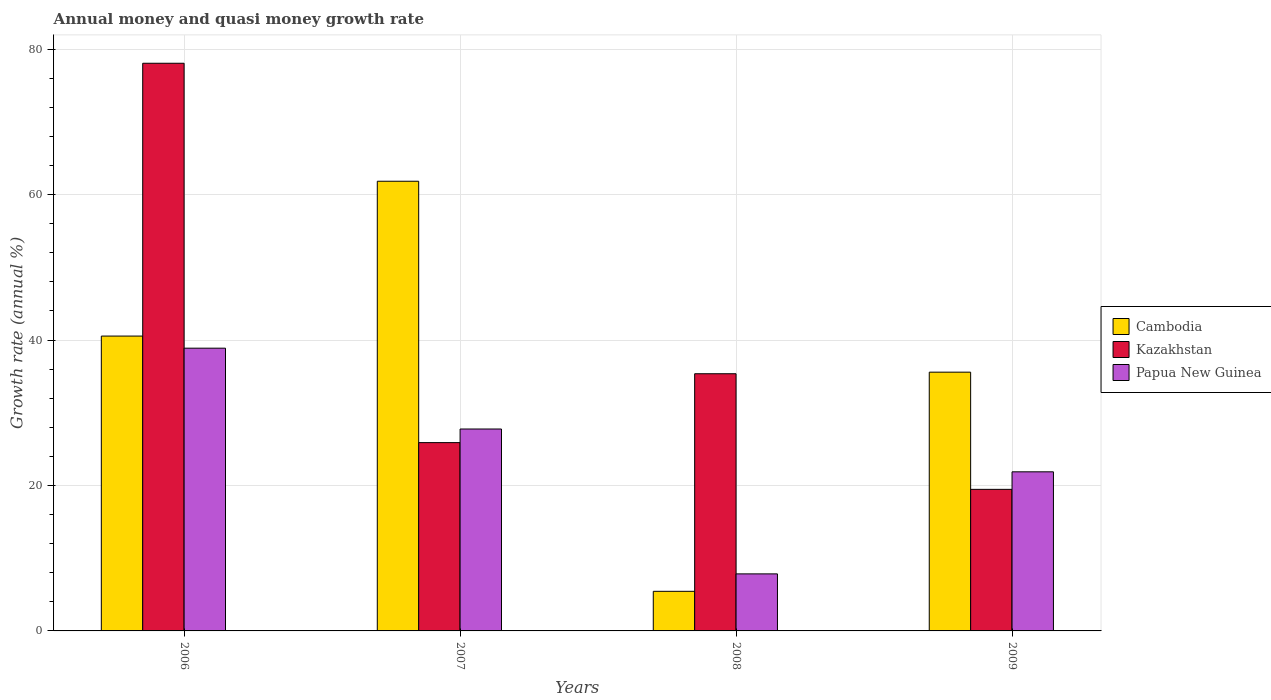How many groups of bars are there?
Make the answer very short. 4. How many bars are there on the 2nd tick from the left?
Provide a short and direct response. 3. How many bars are there on the 4th tick from the right?
Offer a very short reply. 3. What is the label of the 3rd group of bars from the left?
Offer a terse response. 2008. What is the growth rate in Cambodia in 2006?
Offer a very short reply. 40.55. Across all years, what is the maximum growth rate in Cambodia?
Your answer should be very brief. 61.84. Across all years, what is the minimum growth rate in Papua New Guinea?
Your answer should be compact. 7.84. What is the total growth rate in Cambodia in the graph?
Give a very brief answer. 143.41. What is the difference between the growth rate in Kazakhstan in 2007 and that in 2009?
Ensure brevity in your answer.  6.43. What is the difference between the growth rate in Cambodia in 2008 and the growth rate in Kazakhstan in 2009?
Your response must be concise. -14.02. What is the average growth rate in Kazakhstan per year?
Your response must be concise. 39.7. In the year 2006, what is the difference between the growth rate in Papua New Guinea and growth rate in Cambodia?
Your response must be concise. -1.67. What is the ratio of the growth rate in Kazakhstan in 2007 to that in 2008?
Make the answer very short. 0.73. What is the difference between the highest and the second highest growth rate in Papua New Guinea?
Provide a short and direct response. 11.11. What is the difference between the highest and the lowest growth rate in Cambodia?
Offer a very short reply. 56.39. Is the sum of the growth rate in Cambodia in 2006 and 2007 greater than the maximum growth rate in Papua New Guinea across all years?
Your response must be concise. Yes. What does the 2nd bar from the left in 2006 represents?
Offer a very short reply. Kazakhstan. What does the 1st bar from the right in 2009 represents?
Give a very brief answer. Papua New Guinea. Is it the case that in every year, the sum of the growth rate in Kazakhstan and growth rate in Cambodia is greater than the growth rate in Papua New Guinea?
Your response must be concise. Yes. How many bars are there?
Ensure brevity in your answer.  12. How many years are there in the graph?
Make the answer very short. 4. Are the values on the major ticks of Y-axis written in scientific E-notation?
Ensure brevity in your answer.  No. Does the graph contain grids?
Keep it short and to the point. Yes. How are the legend labels stacked?
Offer a terse response. Vertical. What is the title of the graph?
Give a very brief answer. Annual money and quasi money growth rate. What is the label or title of the X-axis?
Make the answer very short. Years. What is the label or title of the Y-axis?
Provide a short and direct response. Growth rate (annual %). What is the Growth rate (annual %) of Cambodia in 2006?
Your answer should be compact. 40.55. What is the Growth rate (annual %) in Kazakhstan in 2006?
Offer a terse response. 78.06. What is the Growth rate (annual %) in Papua New Guinea in 2006?
Provide a succinct answer. 38.88. What is the Growth rate (annual %) in Cambodia in 2007?
Your answer should be very brief. 61.84. What is the Growth rate (annual %) of Kazakhstan in 2007?
Keep it short and to the point. 25.89. What is the Growth rate (annual %) in Papua New Guinea in 2007?
Ensure brevity in your answer.  27.76. What is the Growth rate (annual %) of Cambodia in 2008?
Offer a very short reply. 5.45. What is the Growth rate (annual %) of Kazakhstan in 2008?
Give a very brief answer. 35.37. What is the Growth rate (annual %) of Papua New Guinea in 2008?
Offer a terse response. 7.84. What is the Growth rate (annual %) in Cambodia in 2009?
Your answer should be compact. 35.58. What is the Growth rate (annual %) of Kazakhstan in 2009?
Your answer should be very brief. 19.47. What is the Growth rate (annual %) in Papua New Guinea in 2009?
Your answer should be compact. 21.88. Across all years, what is the maximum Growth rate (annual %) in Cambodia?
Provide a short and direct response. 61.84. Across all years, what is the maximum Growth rate (annual %) in Kazakhstan?
Provide a short and direct response. 78.06. Across all years, what is the maximum Growth rate (annual %) of Papua New Guinea?
Provide a succinct answer. 38.88. Across all years, what is the minimum Growth rate (annual %) in Cambodia?
Your answer should be compact. 5.45. Across all years, what is the minimum Growth rate (annual %) of Kazakhstan?
Offer a very short reply. 19.47. Across all years, what is the minimum Growth rate (annual %) in Papua New Guinea?
Keep it short and to the point. 7.84. What is the total Growth rate (annual %) in Cambodia in the graph?
Ensure brevity in your answer.  143.41. What is the total Growth rate (annual %) in Kazakhstan in the graph?
Give a very brief answer. 158.79. What is the total Growth rate (annual %) in Papua New Guinea in the graph?
Provide a short and direct response. 96.36. What is the difference between the Growth rate (annual %) in Cambodia in 2006 and that in 2007?
Provide a short and direct response. -21.29. What is the difference between the Growth rate (annual %) of Kazakhstan in 2006 and that in 2007?
Offer a terse response. 52.17. What is the difference between the Growth rate (annual %) of Papua New Guinea in 2006 and that in 2007?
Your answer should be very brief. 11.11. What is the difference between the Growth rate (annual %) of Cambodia in 2006 and that in 2008?
Your answer should be compact. 35.1. What is the difference between the Growth rate (annual %) of Kazakhstan in 2006 and that in 2008?
Your answer should be compact. 42.69. What is the difference between the Growth rate (annual %) in Papua New Guinea in 2006 and that in 2008?
Make the answer very short. 31.04. What is the difference between the Growth rate (annual %) of Cambodia in 2006 and that in 2009?
Your answer should be compact. 4.96. What is the difference between the Growth rate (annual %) of Kazakhstan in 2006 and that in 2009?
Your response must be concise. 58.59. What is the difference between the Growth rate (annual %) in Papua New Guinea in 2006 and that in 2009?
Your response must be concise. 17. What is the difference between the Growth rate (annual %) in Cambodia in 2007 and that in 2008?
Your answer should be compact. 56.39. What is the difference between the Growth rate (annual %) of Kazakhstan in 2007 and that in 2008?
Make the answer very short. -9.47. What is the difference between the Growth rate (annual %) of Papua New Guinea in 2007 and that in 2008?
Your answer should be compact. 19.92. What is the difference between the Growth rate (annual %) in Cambodia in 2007 and that in 2009?
Keep it short and to the point. 26.25. What is the difference between the Growth rate (annual %) of Kazakhstan in 2007 and that in 2009?
Your answer should be very brief. 6.43. What is the difference between the Growth rate (annual %) in Papua New Guinea in 2007 and that in 2009?
Provide a short and direct response. 5.89. What is the difference between the Growth rate (annual %) of Cambodia in 2008 and that in 2009?
Ensure brevity in your answer.  -30.14. What is the difference between the Growth rate (annual %) of Kazakhstan in 2008 and that in 2009?
Provide a short and direct response. 15.9. What is the difference between the Growth rate (annual %) in Papua New Guinea in 2008 and that in 2009?
Ensure brevity in your answer.  -14.03. What is the difference between the Growth rate (annual %) in Cambodia in 2006 and the Growth rate (annual %) in Kazakhstan in 2007?
Keep it short and to the point. 14.65. What is the difference between the Growth rate (annual %) of Cambodia in 2006 and the Growth rate (annual %) of Papua New Guinea in 2007?
Offer a very short reply. 12.78. What is the difference between the Growth rate (annual %) of Kazakhstan in 2006 and the Growth rate (annual %) of Papua New Guinea in 2007?
Keep it short and to the point. 50.3. What is the difference between the Growth rate (annual %) in Cambodia in 2006 and the Growth rate (annual %) in Kazakhstan in 2008?
Offer a very short reply. 5.18. What is the difference between the Growth rate (annual %) in Cambodia in 2006 and the Growth rate (annual %) in Papua New Guinea in 2008?
Provide a short and direct response. 32.7. What is the difference between the Growth rate (annual %) in Kazakhstan in 2006 and the Growth rate (annual %) in Papua New Guinea in 2008?
Keep it short and to the point. 70.22. What is the difference between the Growth rate (annual %) of Cambodia in 2006 and the Growth rate (annual %) of Kazakhstan in 2009?
Your answer should be very brief. 21.08. What is the difference between the Growth rate (annual %) of Cambodia in 2006 and the Growth rate (annual %) of Papua New Guinea in 2009?
Give a very brief answer. 18.67. What is the difference between the Growth rate (annual %) in Kazakhstan in 2006 and the Growth rate (annual %) in Papua New Guinea in 2009?
Offer a terse response. 56.18. What is the difference between the Growth rate (annual %) in Cambodia in 2007 and the Growth rate (annual %) in Kazakhstan in 2008?
Offer a terse response. 26.47. What is the difference between the Growth rate (annual %) in Cambodia in 2007 and the Growth rate (annual %) in Papua New Guinea in 2008?
Offer a terse response. 53.99. What is the difference between the Growth rate (annual %) of Kazakhstan in 2007 and the Growth rate (annual %) of Papua New Guinea in 2008?
Offer a very short reply. 18.05. What is the difference between the Growth rate (annual %) of Cambodia in 2007 and the Growth rate (annual %) of Kazakhstan in 2009?
Provide a succinct answer. 42.37. What is the difference between the Growth rate (annual %) in Cambodia in 2007 and the Growth rate (annual %) in Papua New Guinea in 2009?
Your response must be concise. 39.96. What is the difference between the Growth rate (annual %) of Kazakhstan in 2007 and the Growth rate (annual %) of Papua New Guinea in 2009?
Offer a very short reply. 4.02. What is the difference between the Growth rate (annual %) in Cambodia in 2008 and the Growth rate (annual %) in Kazakhstan in 2009?
Give a very brief answer. -14.02. What is the difference between the Growth rate (annual %) in Cambodia in 2008 and the Growth rate (annual %) in Papua New Guinea in 2009?
Provide a succinct answer. -16.43. What is the difference between the Growth rate (annual %) of Kazakhstan in 2008 and the Growth rate (annual %) of Papua New Guinea in 2009?
Ensure brevity in your answer.  13.49. What is the average Growth rate (annual %) of Cambodia per year?
Your answer should be compact. 35.85. What is the average Growth rate (annual %) in Kazakhstan per year?
Make the answer very short. 39.7. What is the average Growth rate (annual %) in Papua New Guinea per year?
Your answer should be compact. 24.09. In the year 2006, what is the difference between the Growth rate (annual %) of Cambodia and Growth rate (annual %) of Kazakhstan?
Ensure brevity in your answer.  -37.51. In the year 2006, what is the difference between the Growth rate (annual %) in Cambodia and Growth rate (annual %) in Papua New Guinea?
Provide a short and direct response. 1.67. In the year 2006, what is the difference between the Growth rate (annual %) in Kazakhstan and Growth rate (annual %) in Papua New Guinea?
Your answer should be very brief. 39.18. In the year 2007, what is the difference between the Growth rate (annual %) in Cambodia and Growth rate (annual %) in Kazakhstan?
Offer a terse response. 35.94. In the year 2007, what is the difference between the Growth rate (annual %) of Cambodia and Growth rate (annual %) of Papua New Guinea?
Offer a very short reply. 34.07. In the year 2007, what is the difference between the Growth rate (annual %) of Kazakhstan and Growth rate (annual %) of Papua New Guinea?
Your response must be concise. -1.87. In the year 2008, what is the difference between the Growth rate (annual %) in Cambodia and Growth rate (annual %) in Kazakhstan?
Your response must be concise. -29.92. In the year 2008, what is the difference between the Growth rate (annual %) of Cambodia and Growth rate (annual %) of Papua New Guinea?
Provide a succinct answer. -2.4. In the year 2008, what is the difference between the Growth rate (annual %) in Kazakhstan and Growth rate (annual %) in Papua New Guinea?
Offer a terse response. 27.52. In the year 2009, what is the difference between the Growth rate (annual %) of Cambodia and Growth rate (annual %) of Kazakhstan?
Give a very brief answer. 16.11. In the year 2009, what is the difference between the Growth rate (annual %) of Cambodia and Growth rate (annual %) of Papua New Guinea?
Give a very brief answer. 13.71. In the year 2009, what is the difference between the Growth rate (annual %) in Kazakhstan and Growth rate (annual %) in Papua New Guinea?
Your response must be concise. -2.41. What is the ratio of the Growth rate (annual %) in Cambodia in 2006 to that in 2007?
Your answer should be compact. 0.66. What is the ratio of the Growth rate (annual %) in Kazakhstan in 2006 to that in 2007?
Ensure brevity in your answer.  3.01. What is the ratio of the Growth rate (annual %) in Papua New Guinea in 2006 to that in 2007?
Offer a very short reply. 1.4. What is the ratio of the Growth rate (annual %) of Cambodia in 2006 to that in 2008?
Provide a short and direct response. 7.45. What is the ratio of the Growth rate (annual %) in Kazakhstan in 2006 to that in 2008?
Provide a succinct answer. 2.21. What is the ratio of the Growth rate (annual %) in Papua New Guinea in 2006 to that in 2008?
Your answer should be compact. 4.96. What is the ratio of the Growth rate (annual %) of Cambodia in 2006 to that in 2009?
Make the answer very short. 1.14. What is the ratio of the Growth rate (annual %) in Kazakhstan in 2006 to that in 2009?
Keep it short and to the point. 4.01. What is the ratio of the Growth rate (annual %) in Papua New Guinea in 2006 to that in 2009?
Make the answer very short. 1.78. What is the ratio of the Growth rate (annual %) of Cambodia in 2007 to that in 2008?
Provide a succinct answer. 11.35. What is the ratio of the Growth rate (annual %) in Kazakhstan in 2007 to that in 2008?
Your response must be concise. 0.73. What is the ratio of the Growth rate (annual %) of Papua New Guinea in 2007 to that in 2008?
Ensure brevity in your answer.  3.54. What is the ratio of the Growth rate (annual %) of Cambodia in 2007 to that in 2009?
Offer a very short reply. 1.74. What is the ratio of the Growth rate (annual %) of Kazakhstan in 2007 to that in 2009?
Provide a succinct answer. 1.33. What is the ratio of the Growth rate (annual %) of Papua New Guinea in 2007 to that in 2009?
Offer a terse response. 1.27. What is the ratio of the Growth rate (annual %) of Cambodia in 2008 to that in 2009?
Give a very brief answer. 0.15. What is the ratio of the Growth rate (annual %) in Kazakhstan in 2008 to that in 2009?
Provide a short and direct response. 1.82. What is the ratio of the Growth rate (annual %) in Papua New Guinea in 2008 to that in 2009?
Make the answer very short. 0.36. What is the difference between the highest and the second highest Growth rate (annual %) of Cambodia?
Your answer should be compact. 21.29. What is the difference between the highest and the second highest Growth rate (annual %) of Kazakhstan?
Keep it short and to the point. 42.69. What is the difference between the highest and the second highest Growth rate (annual %) in Papua New Guinea?
Provide a short and direct response. 11.11. What is the difference between the highest and the lowest Growth rate (annual %) in Cambodia?
Give a very brief answer. 56.39. What is the difference between the highest and the lowest Growth rate (annual %) in Kazakhstan?
Make the answer very short. 58.59. What is the difference between the highest and the lowest Growth rate (annual %) in Papua New Guinea?
Your answer should be compact. 31.04. 